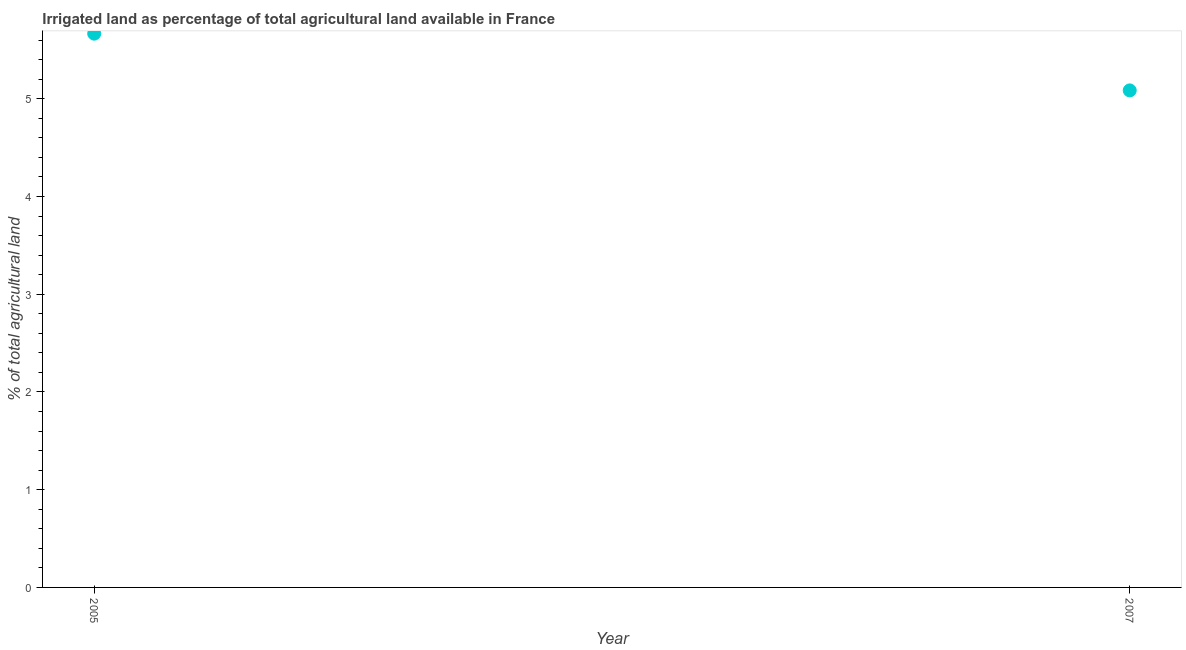What is the percentage of agricultural irrigated land in 2005?
Your answer should be very brief. 5.67. Across all years, what is the maximum percentage of agricultural irrigated land?
Ensure brevity in your answer.  5.67. Across all years, what is the minimum percentage of agricultural irrigated land?
Keep it short and to the point. 5.09. What is the sum of the percentage of agricultural irrigated land?
Give a very brief answer. 10.75. What is the difference between the percentage of agricultural irrigated land in 2005 and 2007?
Your response must be concise. 0.58. What is the average percentage of agricultural irrigated land per year?
Give a very brief answer. 5.38. What is the median percentage of agricultural irrigated land?
Make the answer very short. 5.38. Do a majority of the years between 2007 and 2005 (inclusive) have percentage of agricultural irrigated land greater than 3.6 %?
Your answer should be compact. No. What is the ratio of the percentage of agricultural irrigated land in 2005 to that in 2007?
Ensure brevity in your answer.  1.11. Are the values on the major ticks of Y-axis written in scientific E-notation?
Offer a very short reply. No. What is the title of the graph?
Provide a short and direct response. Irrigated land as percentage of total agricultural land available in France. What is the label or title of the Y-axis?
Ensure brevity in your answer.  % of total agricultural land. What is the % of total agricultural land in 2005?
Give a very brief answer. 5.67. What is the % of total agricultural land in 2007?
Your answer should be compact. 5.09. What is the difference between the % of total agricultural land in 2005 and 2007?
Offer a terse response. 0.58. What is the ratio of the % of total agricultural land in 2005 to that in 2007?
Keep it short and to the point. 1.11. 